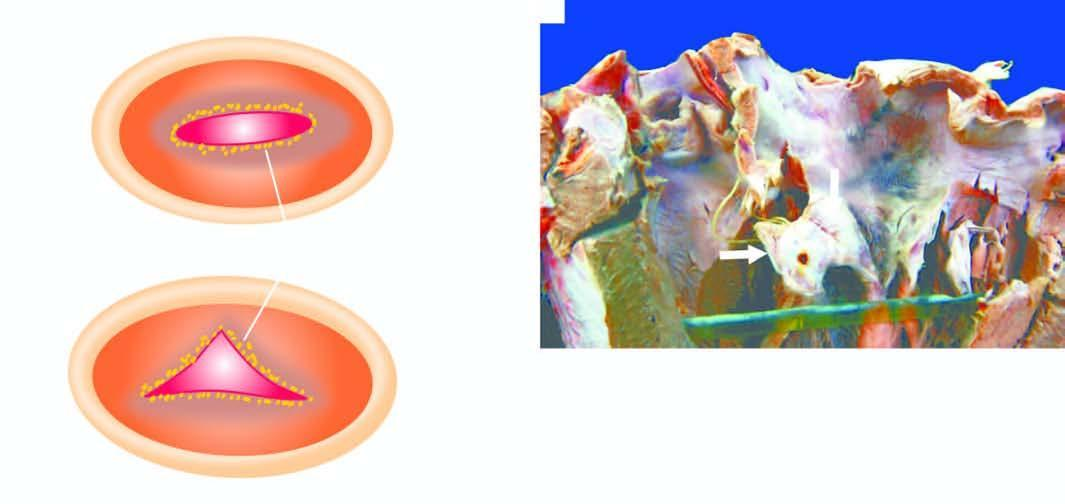re some leucocytes and red cells and a tight meshwork shown as seen from the left ventricular surface?
Answer the question using a single word or phrase. No 